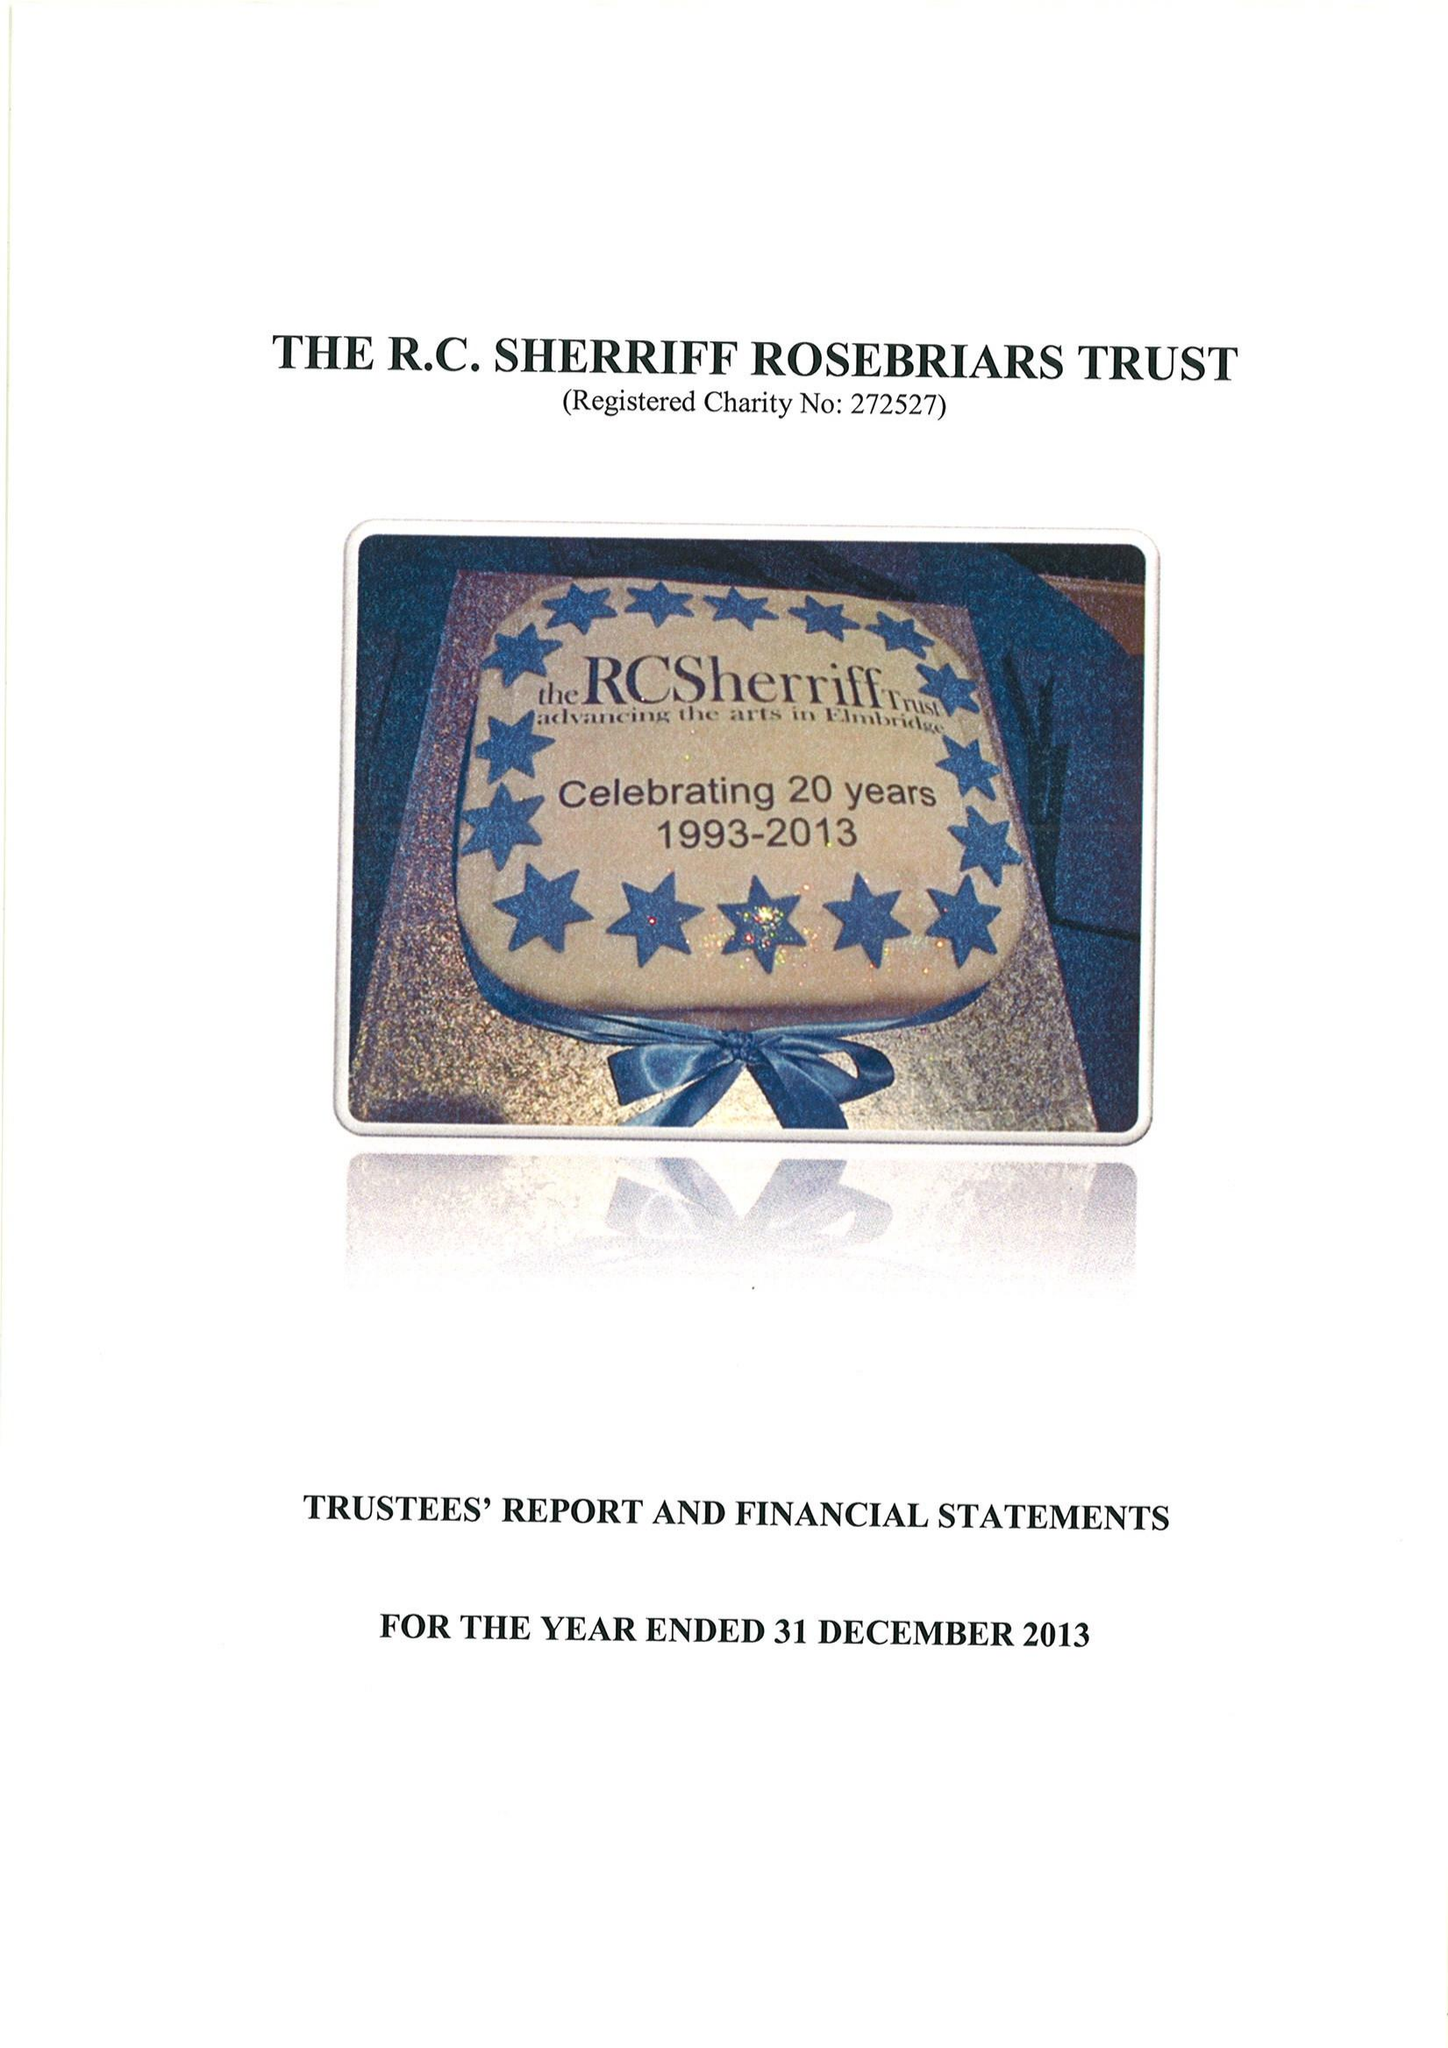What is the value for the address__postcode?
Answer the question using a single word or phrase. KT10 9SD 